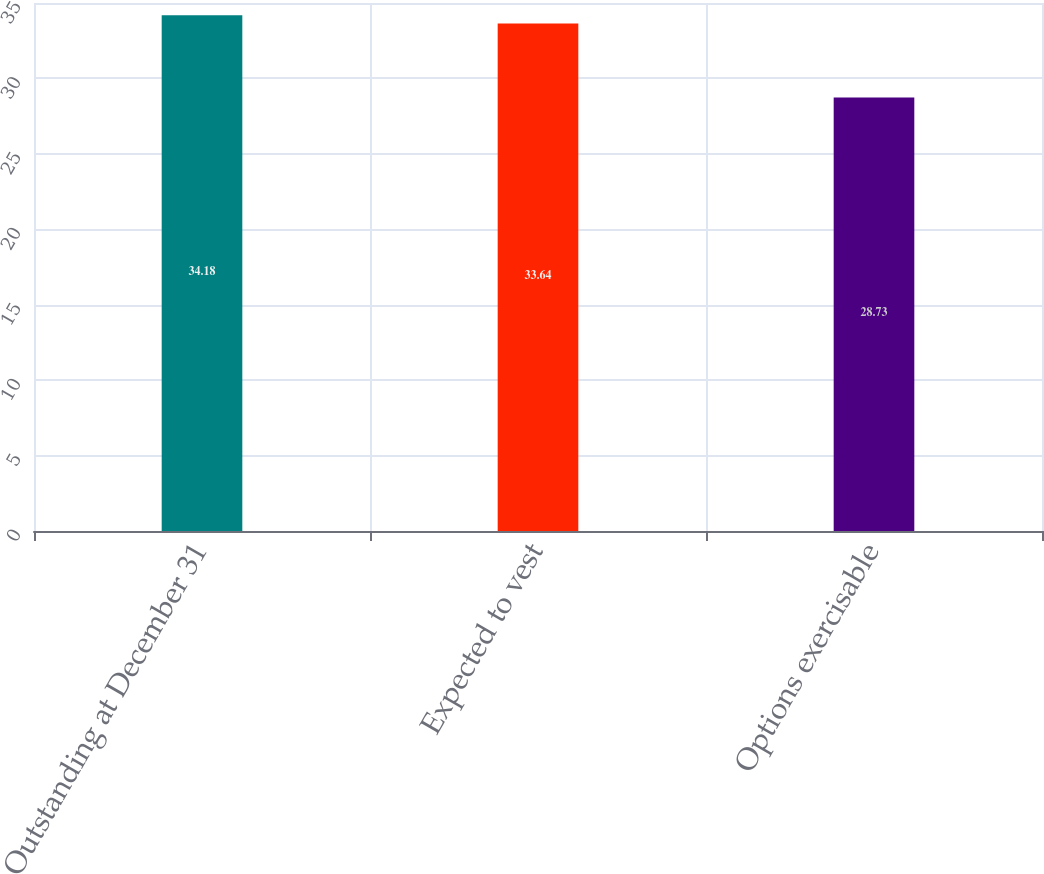<chart> <loc_0><loc_0><loc_500><loc_500><bar_chart><fcel>Outstanding at December 31<fcel>Expected to vest<fcel>Options exercisable<nl><fcel>34.18<fcel>33.64<fcel>28.73<nl></chart> 